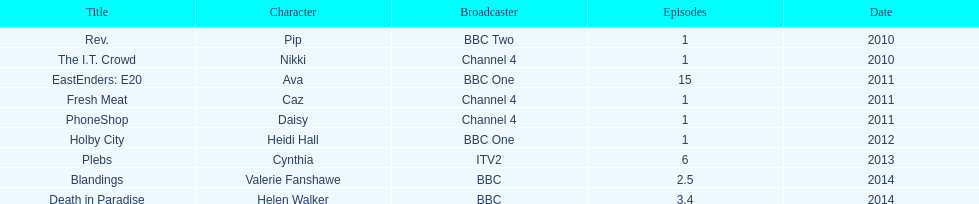Which broadcaster aired both blandings and death in paradise? BBC. 